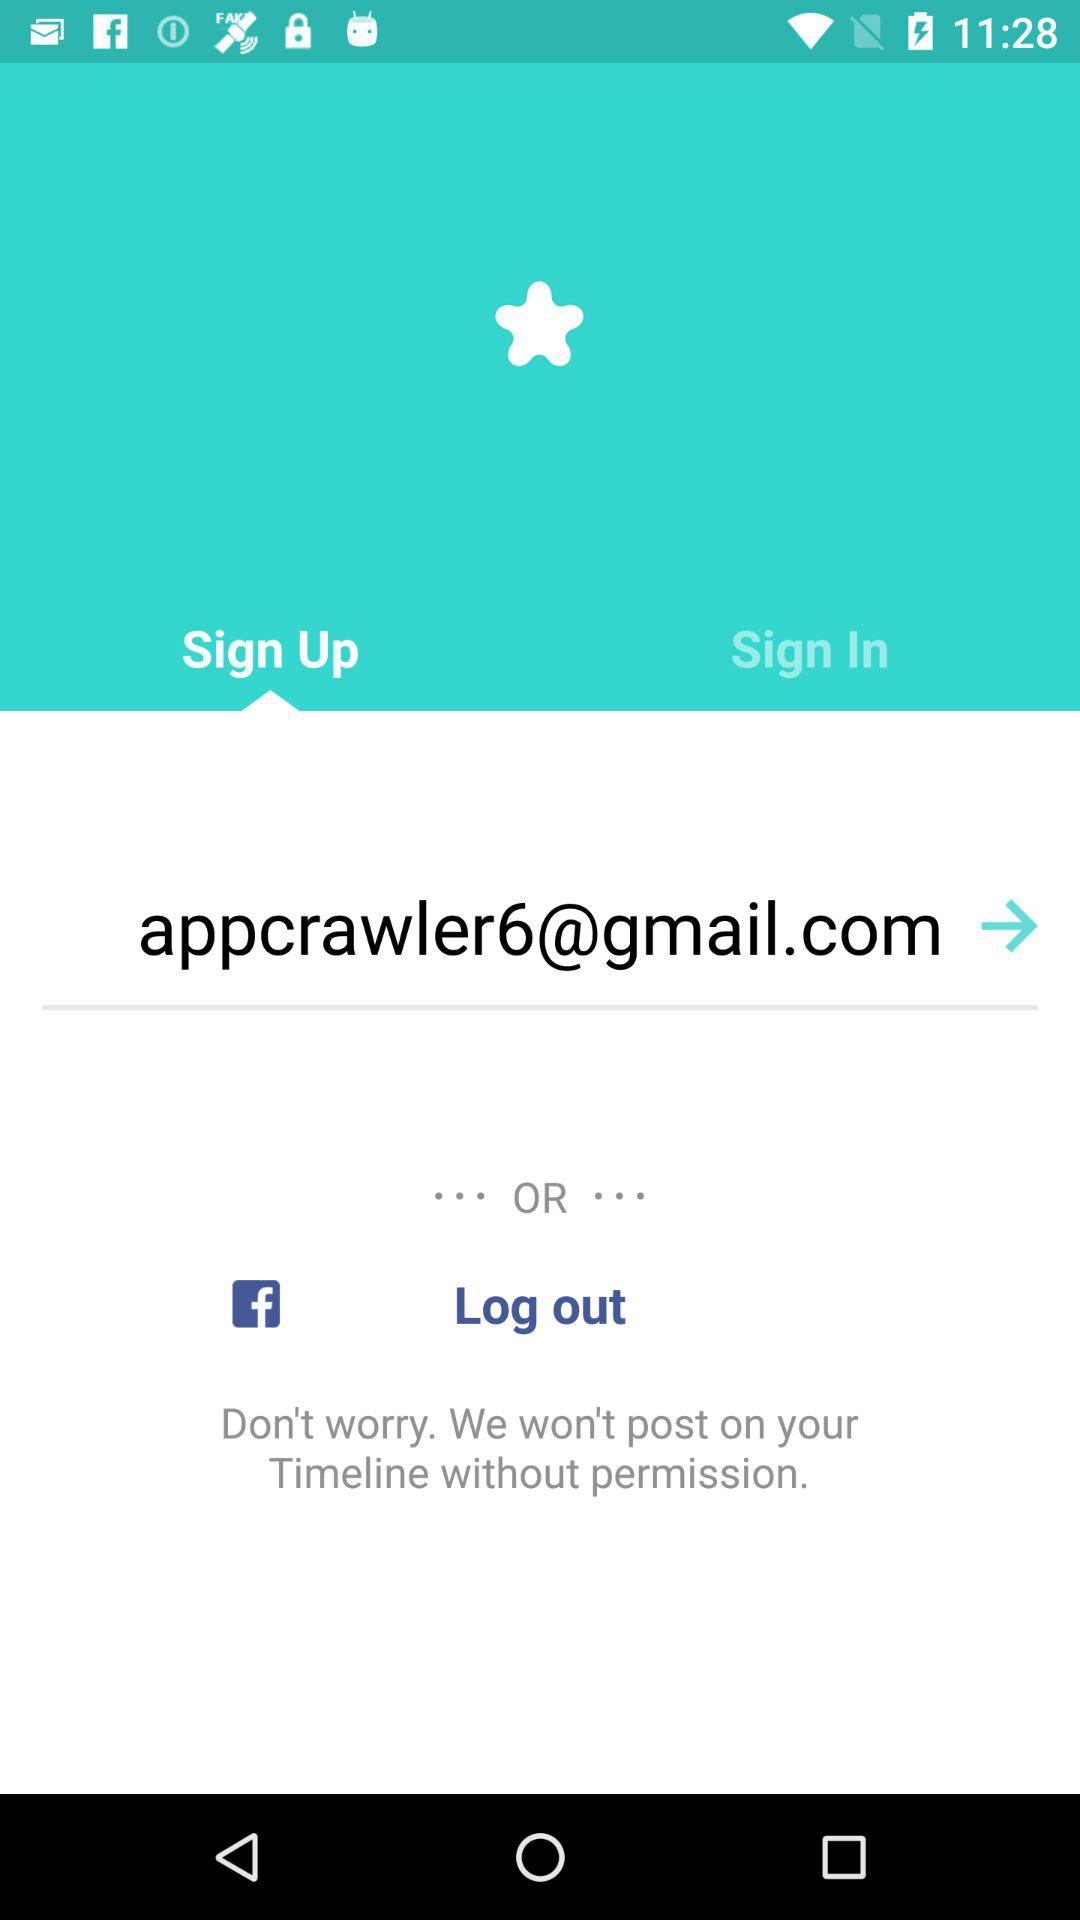What other applications are used for sign-up? The other application is Facebook. 